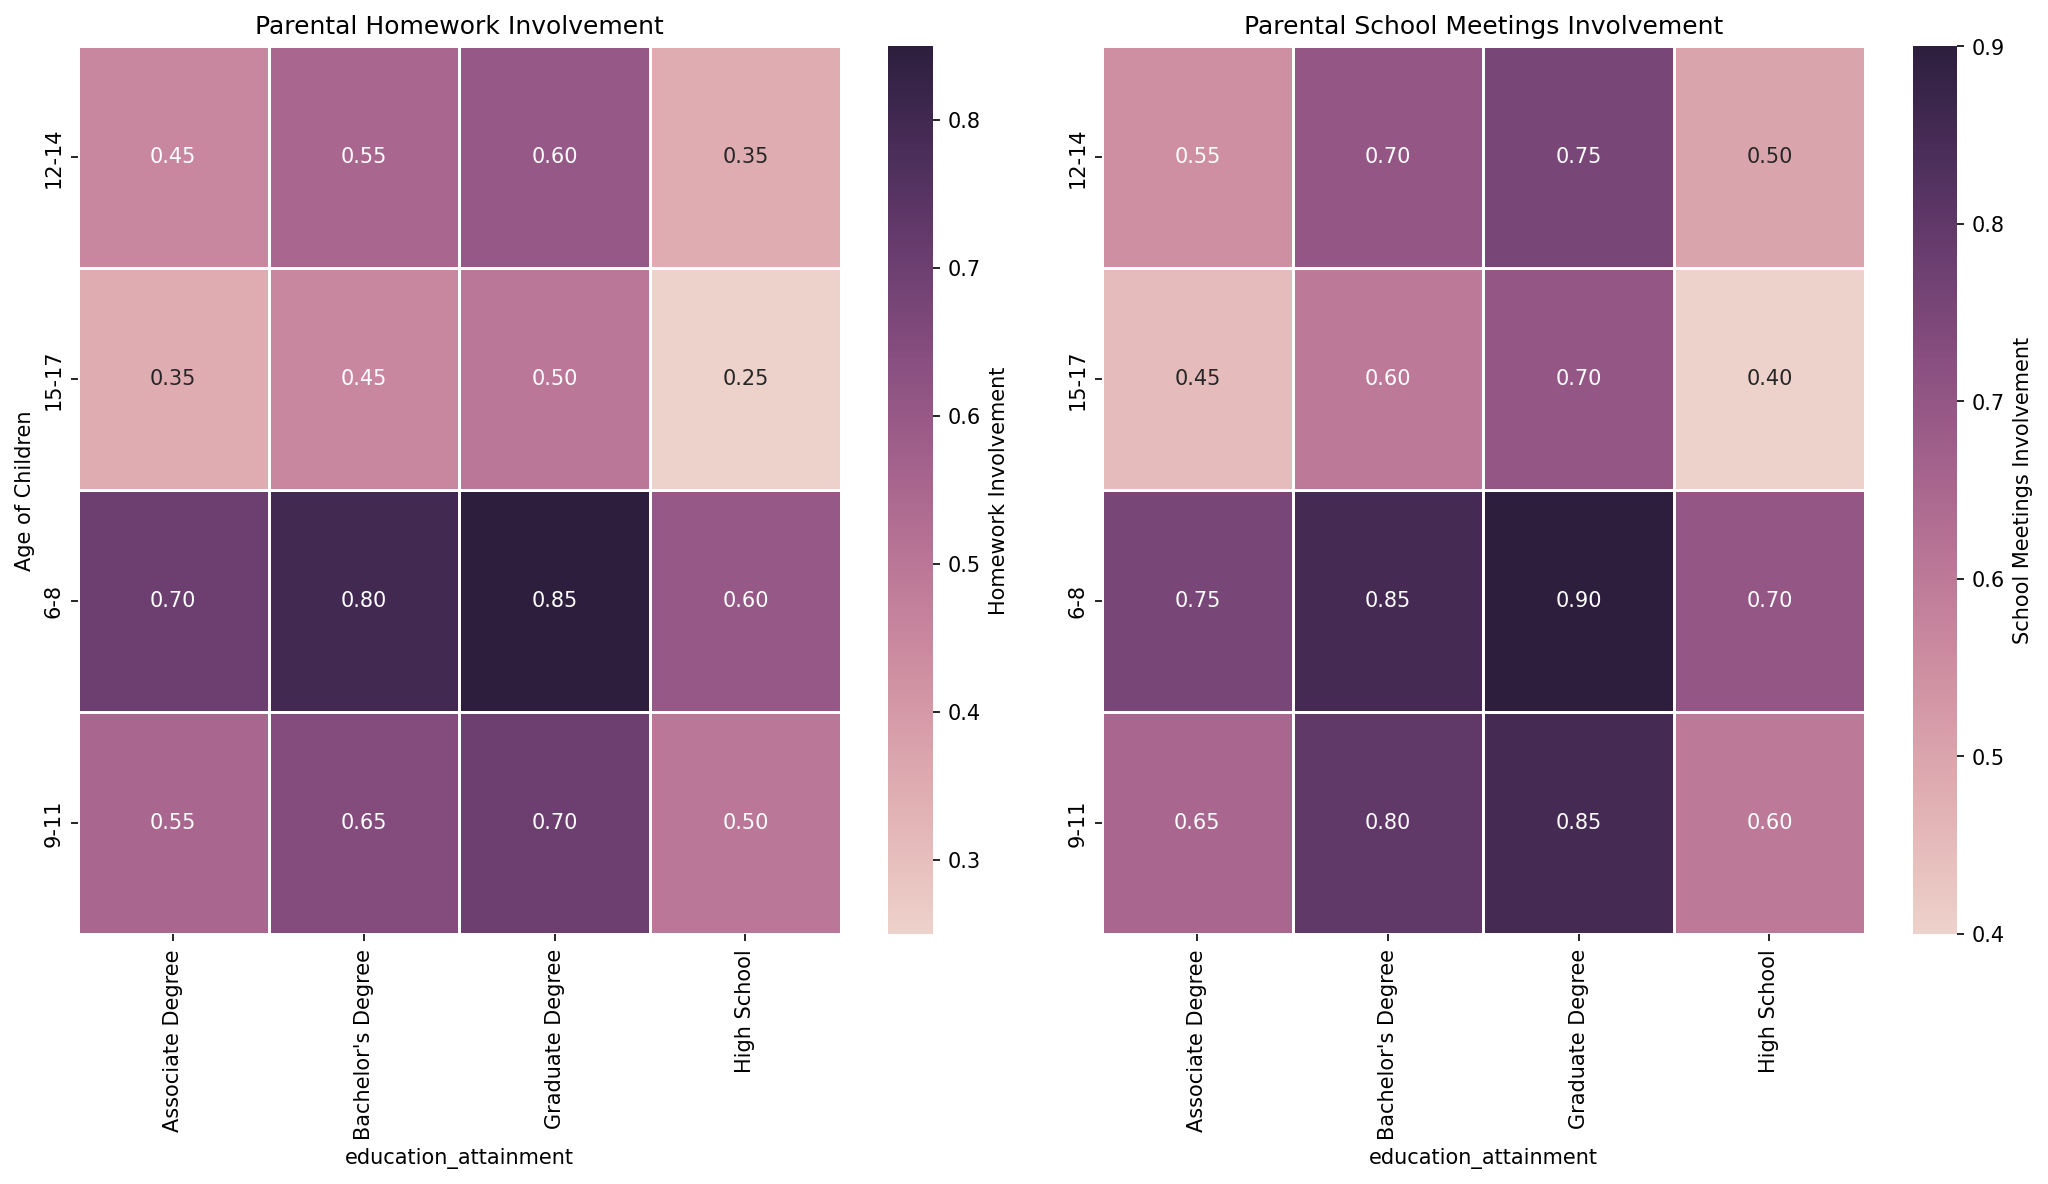Which age group shows the highest parental involvement in school meetings for children with a Bachelor's Degree? From the heatmap, the highest value for parental involvement in school meetings under the Bachelor's Degree category is for age group 9-11.
Answer: 9-11 What is the difference in homework involvement for parents with an Associate Degree between children ages 6-8 and 15-17? For children ages 6-8 with parents who have an Associate Degree, the involvement is 0.7. For ages 15-17, it is 0.35. The difference is 0.7 - 0.35 = 0.35.
Answer: 0.35 Compare the parental involvement in homework and school meetings for children aged 12-14 with a Graduate Degree. Which is higher? For children aged 12-14 with a Graduate Degree, homework involvement is 0.6 and school meetings involvement is 0.75. 0.75 is higher than 0.6.
Answer: School meetings Which educational attainment category has the least parental involvement in homework for children aged 15-17? For children aged 15-17, the homework involvement values are 0.25 for High School, 0.35 for Associate Degree, 0.45 for Bachelor's Degree, and 0.5 for Graduate Degree. The least value is 0.25 for High School.
Answer: High School What is the average parental involvement in school meetings for children aged 9-11 across all educational attainment categories? Involvement in school meetings for age group 9-11: High School (0.6), Associate Degree (0.65), Bachelor's Degree (0.8), Graduate Degree (0.85). The average is (0.6 + 0.65 + 0.8 + 0.85) / 4 = 0.725.
Answer: 0.725 How does parental involvement in homework change from ages 6-8 to 15-17 for parents with a High School education? For parents with a High School education, involvement in homework is 0.6 for ages 6-8 and 0.25 for ages 15-17. It decreases by 0.6 - 0.25 = 0.35.
Answer: Decreases by 0.35 For children aged 6-8, which has the higher parental involvement: homework for Bachelor's Degree or school meetings for High School? For children aged 6-8, parental involvement in homework with a Bachelor's Degree is 0.8, and in school meetings with a High School education is 0.7. 0.8 is higher than 0.7.
Answer: Homework for Bachelor's Degree Identify the age group and educational attainment with the least parental involvement in school meetings. The heatmap shows the least parental involvement in school meetings for ages 15-17 with a High School education at 0.4.
Answer: 15-17, High School What is the relationship between educational attainment and parental involvement in homework for children aged 12-14? For children aged 12-14, homework involvement increases with educational attainment: High School (0.35), Associate Degree (0.45), Bachelor's Degree (0.55), Graduate Degree (0.6).
Answer: Increases with educational attainment Compute the total parental involvement in school meetings for age groups 6-8 and 9-11 with Graduate Degrees. For age group 6-8, involvement is 0.9. For age group 9-11, involvement is 0.85. The total is 0.9 + 0.85 = 1.75.
Answer: 1.75 